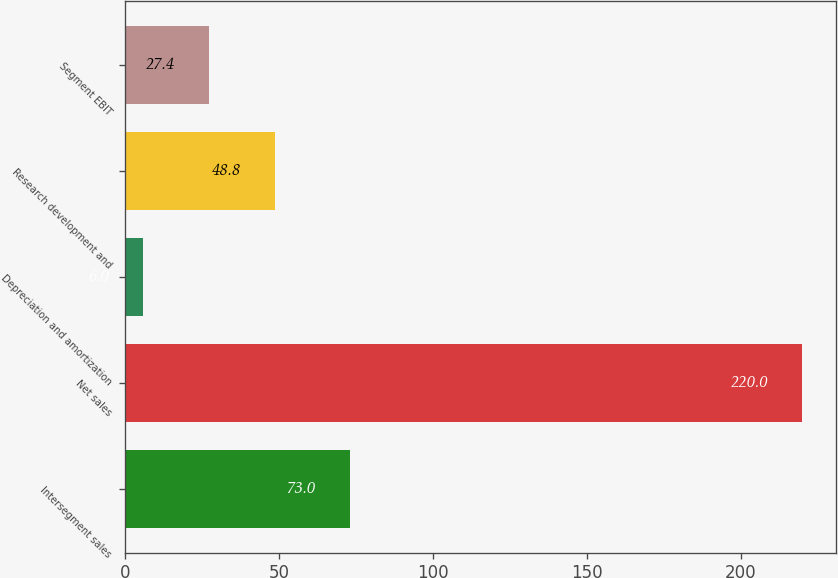Convert chart to OTSL. <chart><loc_0><loc_0><loc_500><loc_500><bar_chart><fcel>Intersegment sales<fcel>Net sales<fcel>Depreciation and amortization<fcel>Research development and<fcel>Segment EBIT<nl><fcel>73<fcel>220<fcel>6<fcel>48.8<fcel>27.4<nl></chart> 